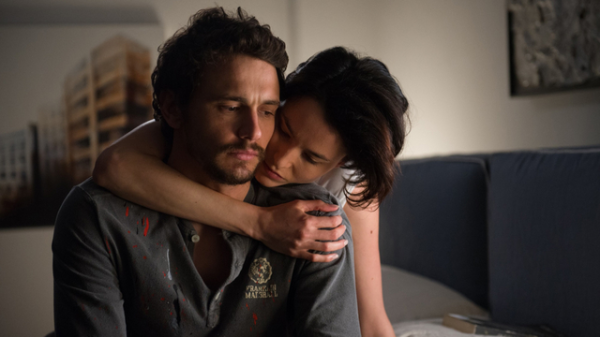Can you describe the mood of the scene depicted? The mood in the scene is deeply emotional and contemplative. The man's expression is serious and pensive, suggesting inner turmoil or reflection. The woman's embrace is tender and comforting, providing a sense of solace and support. The subdued lighting and the intimate composition underscore the emotional intensity and the connection between the two individuals. What do you think the relationship between the two individuals could be? The relationship between the two individuals appears to be one of deep emotional connection and support. The woman's comforting embrace suggests she cares deeply for the man and is trying to provide him with some relief or consolation. They could be close friends, siblings, or romantic partners. The emotional gravity of the scene hints at a significant bond between them, marked by empathy and understanding. What could be the story behind this image? In a quiet apartment, late in the evening, Daniel and Sarah sit together on the couch. Daniel, weighed down by the trials of the past few months, reflects on the challenges he's faced – the loss of a loved one, the pressures at work, and the solitude he's felt. Sarah, his childhood friend who has always been his rock, senses his turmoil without him needing to say a word. She gently embraces him, her presence a silent promise that he is not alone in his pain. The painting on the wall, a piece they both admired on a trip abroad, now serves as a reminder of better times and the resilience of their friendship. Though words are scarce, the comfort and understanding in Sarah's embrace speak volumes, offering Daniel a moment of peace amidst the chaos. 